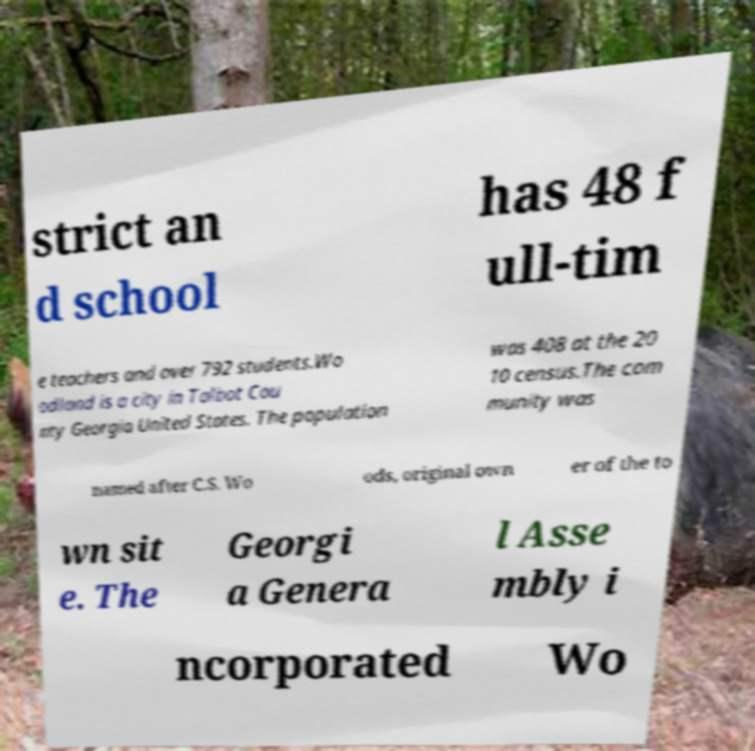Can you accurately transcribe the text from the provided image for me? strict an d school has 48 f ull-tim e teachers and over 792 students.Wo odland is a city in Talbot Cou nty Georgia United States. The population was 408 at the 20 10 census.The com munity was named after C.S. Wo ods, original own er of the to wn sit e. The Georgi a Genera l Asse mbly i ncorporated Wo 